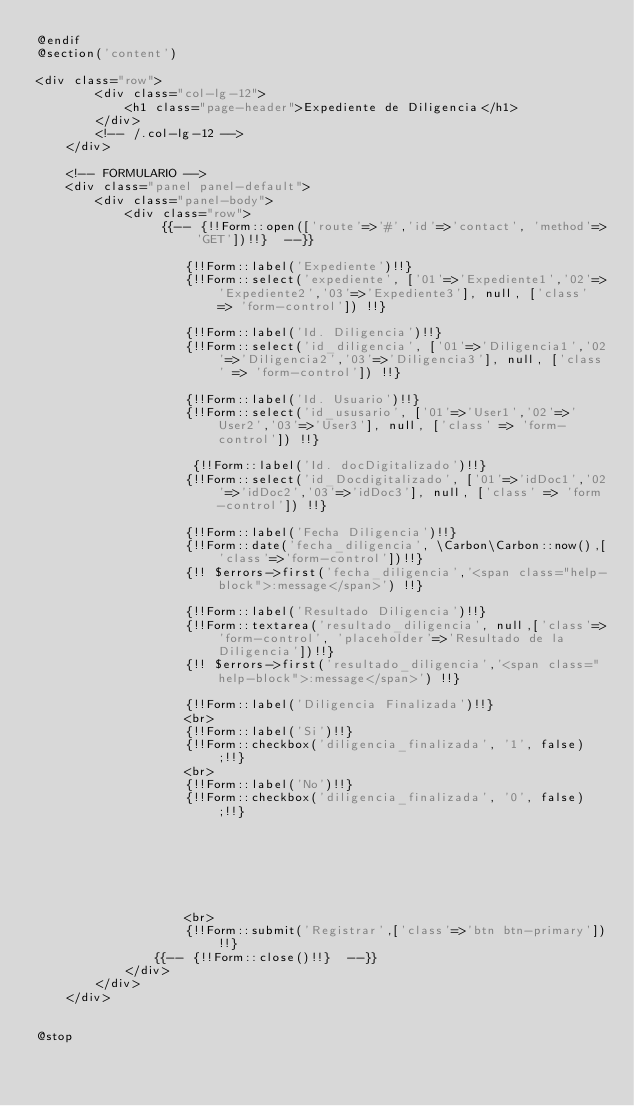Convert code to text. <code><loc_0><loc_0><loc_500><loc_500><_PHP_>@endif
@section('content')

<div class="row">
        <div class="col-lg-12">
            <h1 class="page-header">Expediente de Diligencia</h1>
        </div>
        <!-- /.col-lg-12 -->
    </div>

    <!-- FORMULARIO -->
    <div class="panel panel-default">
        <div class="panel-body">
            <div class="row">
                 {{-- {!!Form::open(['route'=>'#','id'=>'contact', 'method'=>'GET'])!!}  --}}

                    {!!Form::label('Expediente')!!}
                    {!!Form::select('expediente', ['01'=>'Expediente1','02'=>'Expediente2','03'=>'Expediente3'], null, ['class' => 'form-control']) !!}

                    {!!Form::label('Id. Diligencia')!!}
                    {!!Form::select('id_diligencia', ['01'=>'Diligencia1','02'=>'Diligencia2','03'=>'Diligencia3'], null, ['class' => 'form-control']) !!}

                    {!!Form::label('Id. Usuario')!!}
                    {!!Form::select('id_ususario', ['01'=>'User1','02'=>'User2','03'=>'User3'], null, ['class' => 'form-control']) !!}

                     {!!Form::label('Id. docDigitalizado')!!}
                    {!!Form::select('id_Docdigitalizado', ['01'=>'idDoc1','02'=>'idDoc2','03'=>'idDoc3'], null, ['class' => 'form-control']) !!}

                    {!!Form::label('Fecha Diligencia')!!}
                    {!!Form::date('fecha_diligencia', \Carbon\Carbon::now(),['class'=>'form-control'])!!}
                    {!! $errors->first('fecha_diligencia','<span class="help-block">:message</span>') !!}

                    {!!Form::label('Resultado Diligencia')!!}
                    {!!Form::textarea('resultado_diligencia', null,['class'=>'form-control', 'placeholder'=>'Resultado de la Diligencia'])!!}
                    {!! $errors->first('resultado_diligencia','<span class="help-block">:message</span>') !!}

                    {!!Form::label('Diligencia Finalizada')!!}
                    <br>
                    {!!Form::label('Si')!!}
                    {!!Form::checkbox('diligencia_finalizada', '1', false);!!}
                    <br>
                    {!!Form::label('No')!!}
                    {!!Form::checkbox('diligencia_finalizada', '0', false);!!}




                   


                    <br>
                    {!!Form::submit('Registrar',['class'=>'btn btn-primary'])!!} 
                {{-- {!!Form::close()!!}  --}}
            </div>
        </div>
    </div>


@stop
</code> 